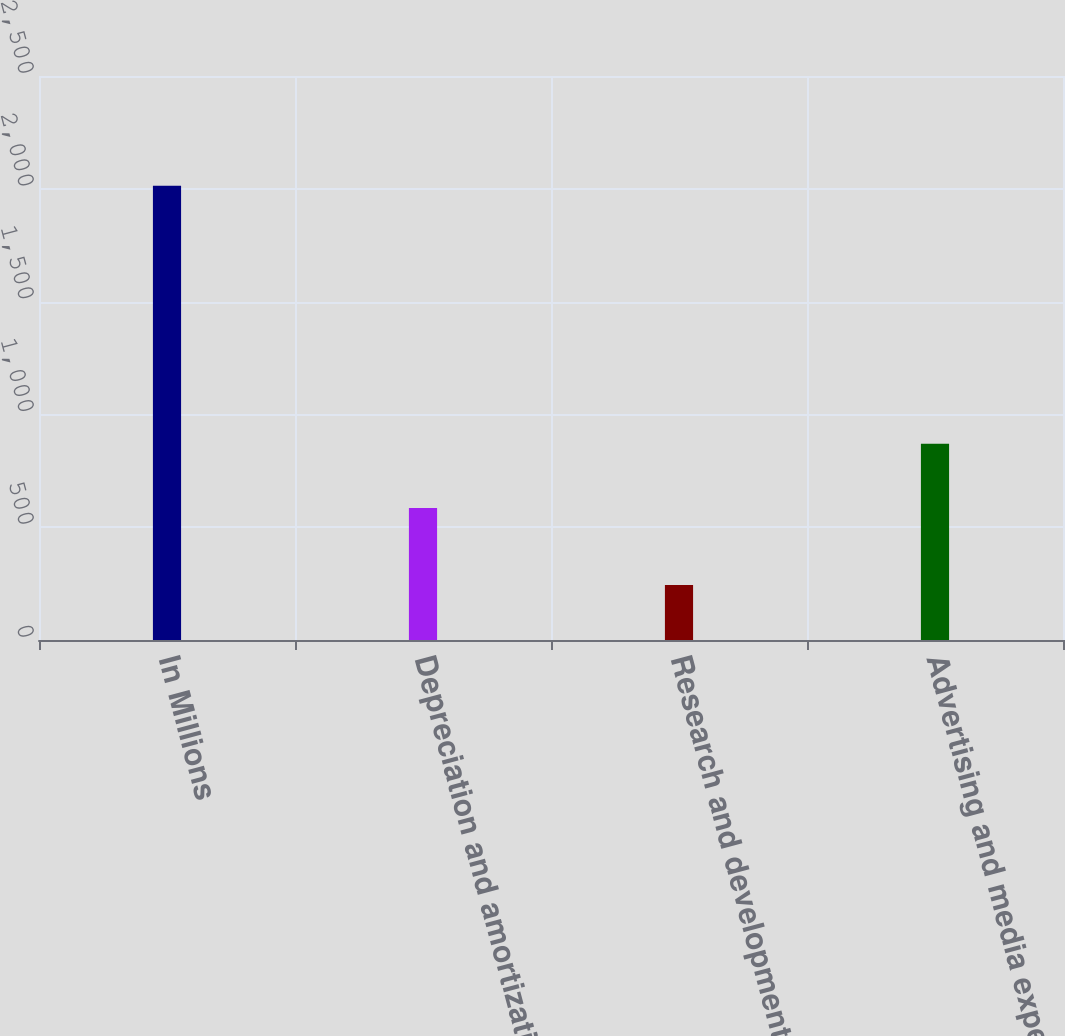<chart> <loc_0><loc_0><loc_500><loc_500><bar_chart><fcel>In Millions<fcel>Depreciation and amortization<fcel>Research and development<fcel>Advertising and media expense<nl><fcel>2014<fcel>585.4<fcel>243.6<fcel>869.5<nl></chart> 